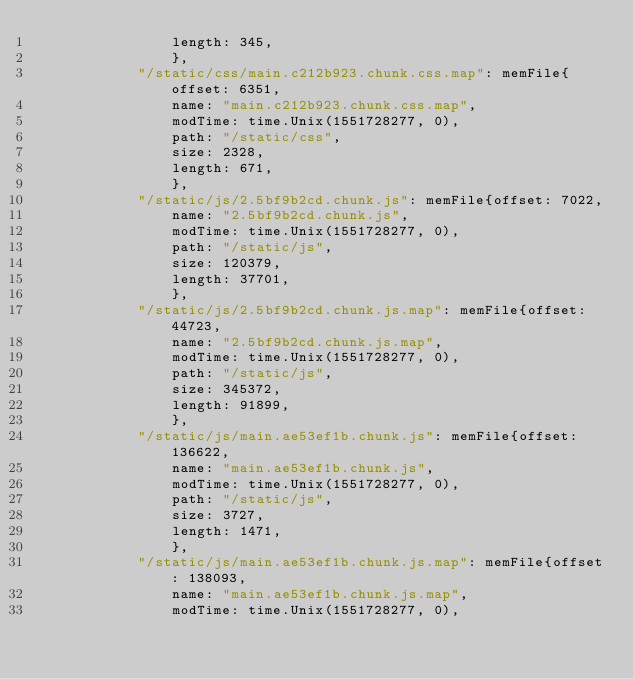Convert code to text. <code><loc_0><loc_0><loc_500><loc_500><_Go_>				length: 345,
				},
			"/static/css/main.c212b923.chunk.css.map": memFile{offset: 6351,
				name: "main.c212b923.chunk.css.map",
				modTime: time.Unix(1551728277, 0),
				path: "/static/css",
				size: 2328,
				length: 671,
				},
			"/static/js/2.5bf9b2cd.chunk.js": memFile{offset: 7022,
				name: "2.5bf9b2cd.chunk.js",
				modTime: time.Unix(1551728277, 0),
				path: "/static/js",
				size: 120379,
				length: 37701,
				},
			"/static/js/2.5bf9b2cd.chunk.js.map": memFile{offset: 44723,
				name: "2.5bf9b2cd.chunk.js.map",
				modTime: time.Unix(1551728277, 0),
				path: "/static/js",
				size: 345372,
				length: 91899,
				},
			"/static/js/main.ae53ef1b.chunk.js": memFile{offset: 136622,
				name: "main.ae53ef1b.chunk.js",
				modTime: time.Unix(1551728277, 0),
				path: "/static/js",
				size: 3727,
				length: 1471,
				},
			"/static/js/main.ae53ef1b.chunk.js.map": memFile{offset: 138093,
				name: "main.ae53ef1b.chunk.js.map",
				modTime: time.Unix(1551728277, 0),</code> 